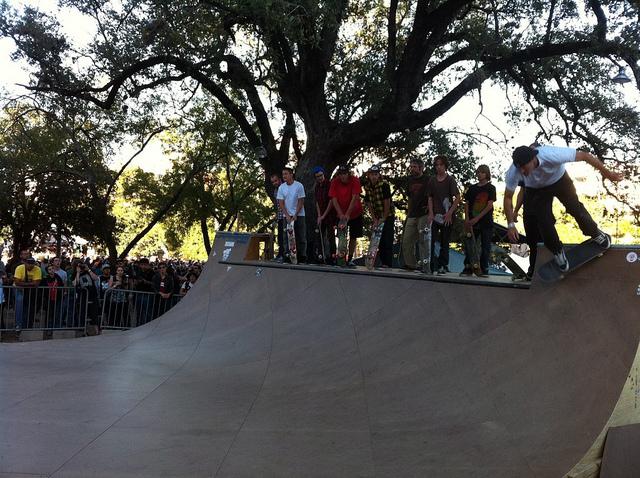Is this a skate park?
Answer briefly. Yes. How many skateboard are there?
Quick response, please. 7. What are the boys doing at the top of the ramp?
Give a very brief answer. Skateboarding. Are they getting ready to do a competition?
Write a very short answer. Yes. What is behind the skateboarders?
Short answer required. Tree. How many females are in this picture?
Give a very brief answer. 0. How tall is the ramp?
Write a very short answer. 4 feet. 